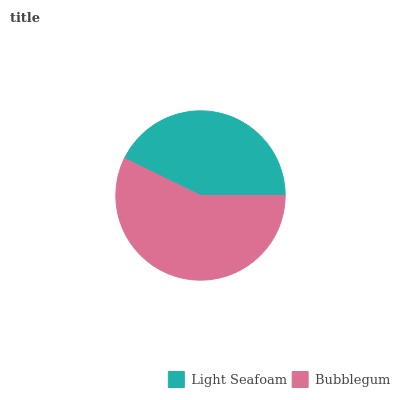Is Light Seafoam the minimum?
Answer yes or no. Yes. Is Bubblegum the maximum?
Answer yes or no. Yes. Is Bubblegum the minimum?
Answer yes or no. No. Is Bubblegum greater than Light Seafoam?
Answer yes or no. Yes. Is Light Seafoam less than Bubblegum?
Answer yes or no. Yes. Is Light Seafoam greater than Bubblegum?
Answer yes or no. No. Is Bubblegum less than Light Seafoam?
Answer yes or no. No. Is Bubblegum the high median?
Answer yes or no. Yes. Is Light Seafoam the low median?
Answer yes or no. Yes. Is Light Seafoam the high median?
Answer yes or no. No. Is Bubblegum the low median?
Answer yes or no. No. 